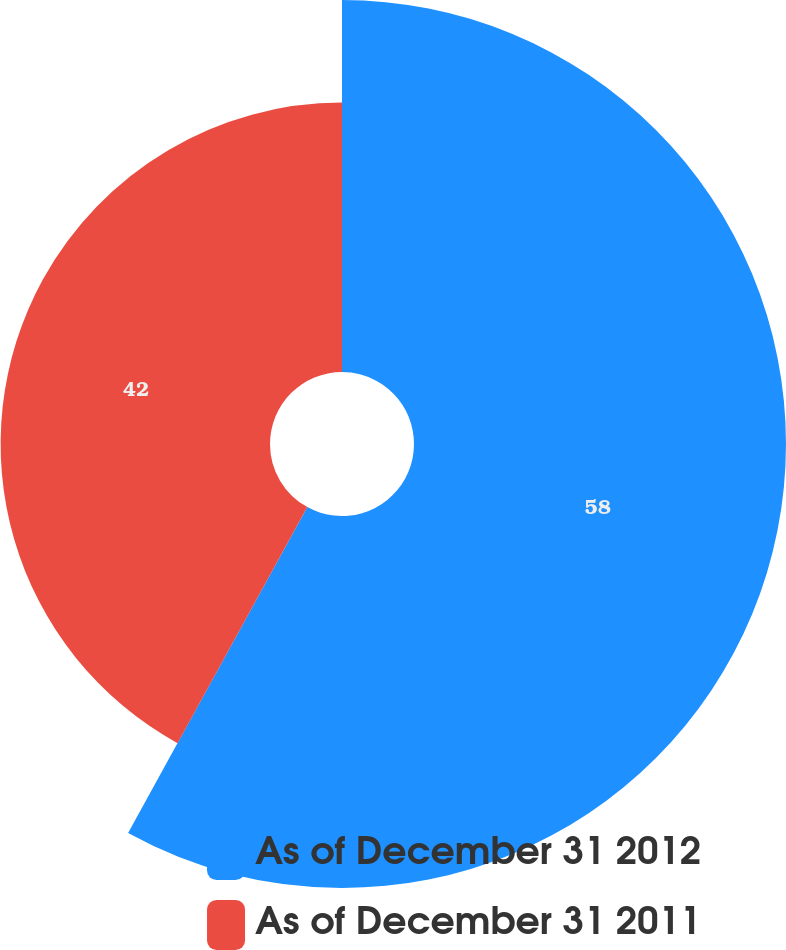Convert chart to OTSL. <chart><loc_0><loc_0><loc_500><loc_500><pie_chart><fcel>As of December 31 2012<fcel>As of December 31 2011<nl><fcel>58.0%<fcel>42.0%<nl></chart> 